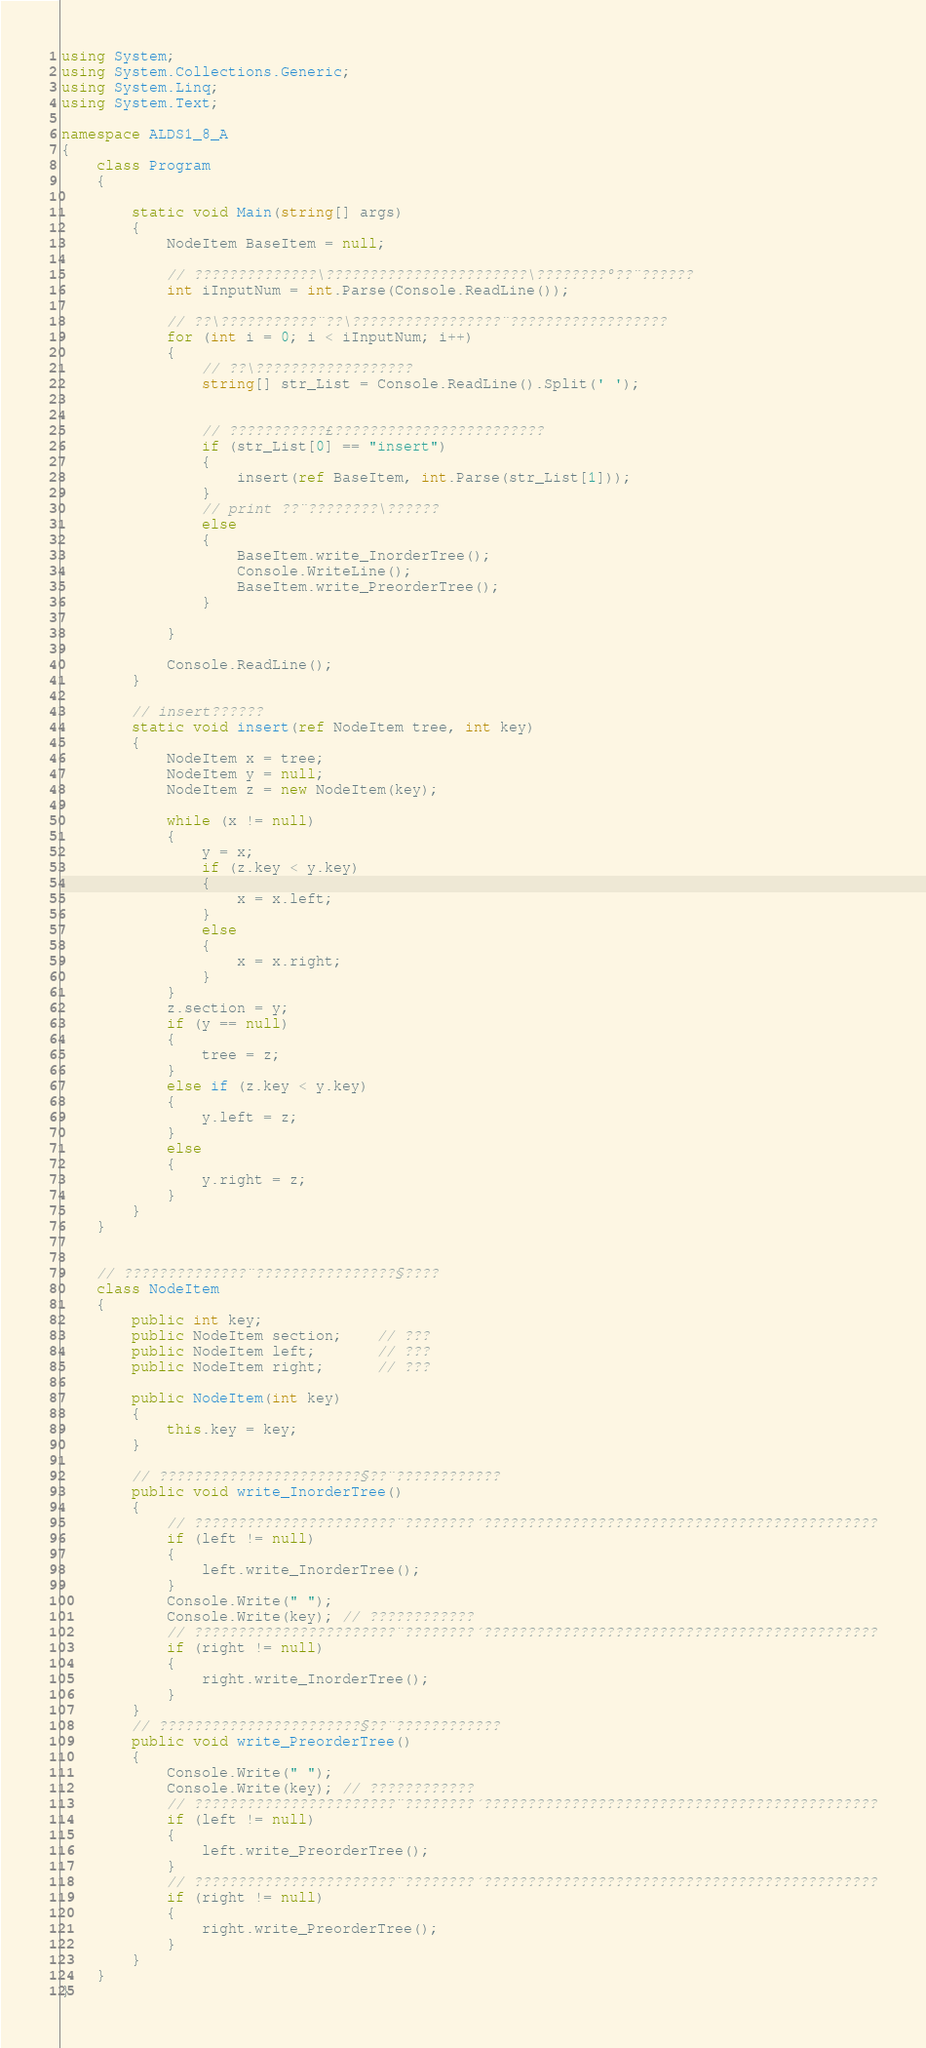Convert code to text. <code><loc_0><loc_0><loc_500><loc_500><_C#_>using System;
using System.Collections.Generic;
using System.Linq;
using System.Text;

namespace ALDS1_8_A
{
    class Program
    {
 
        static void Main(string[] args)
        {
            NodeItem BaseItem = null;

            // ??????????????\???????????????????????\????????°??¨??????
            int iInputNum = int.Parse(Console.ReadLine());

            // ??\???????????¨??\?????????????????¨??????????????????
            for (int i = 0; i < iInputNum; i++)
            {
                // ??\??????????????????
                string[] str_List = Console.ReadLine().Split(' ');


                // ???????????£????????????????????????
                if (str_List[0] == "insert")
                {
                    insert(ref BaseItem, int.Parse(str_List[1]));
                }
                // print ??¨????????\??????
                else
                {
                    BaseItem.write_InorderTree();
                    Console.WriteLine();
                    BaseItem.write_PreorderTree();
                }

            }

            Console.ReadLine();
        }

        // insert??????
        static void insert(ref NodeItem tree, int key)
        {
            NodeItem x = tree;
            NodeItem y = null;
            NodeItem z = new NodeItem(key);

            while (x != null)
            {
                y = x;
                if (z.key < y.key)
                {
                    x = x.left;
                }
                else
                {
                    x = x.right;
                }
            }
            z.section = y;
            if (y == null)
            {
                tree = z;
            }
            else if (z.key < y.key)
            {
                y.left = z;
            }
            else
            {
                y.right = z;
            }
        }
    }


    // ??????????????¨????????????????§????
    class NodeItem
    {
        public int key;
        public NodeItem section;    // ???
        public NodeItem left;       // ???
        public NodeItem right;      // ???

        public NodeItem(int key)
        {
            this.key = key;
        }

        // ???????????????????????§??¨????????????
        public void write_InorderTree()
        {
            // ???????????????????????¨????????´?????????????????????????????????????????????
            if (left != null)
            {
                left.write_InorderTree();
            }
            Console.Write(" ");
            Console.Write(key); // ????????????
            // ???????????????????????¨????????´?????????????????????????????????????????????
            if (right != null)
            {
                right.write_InorderTree();
            }
        }
        // ???????????????????????§??¨????????????
        public void write_PreorderTree()
        {
            Console.Write(" ");
            Console.Write(key); // ????????????
            // ???????????????????????¨????????´?????????????????????????????????????????????
            if (left != null)
            {
                left.write_PreorderTree();
            }
            // ???????????????????????¨????????´?????????????????????????????????????????????
            if (right != null)
            {
                right.write_PreorderTree();
            }
        }
    }
}</code> 